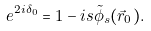<formula> <loc_0><loc_0><loc_500><loc_500>e ^ { 2 i \delta _ { 0 } } = 1 - i s \tilde { \phi } _ { s } ( \vec { r } _ { 0 } ) .</formula> 